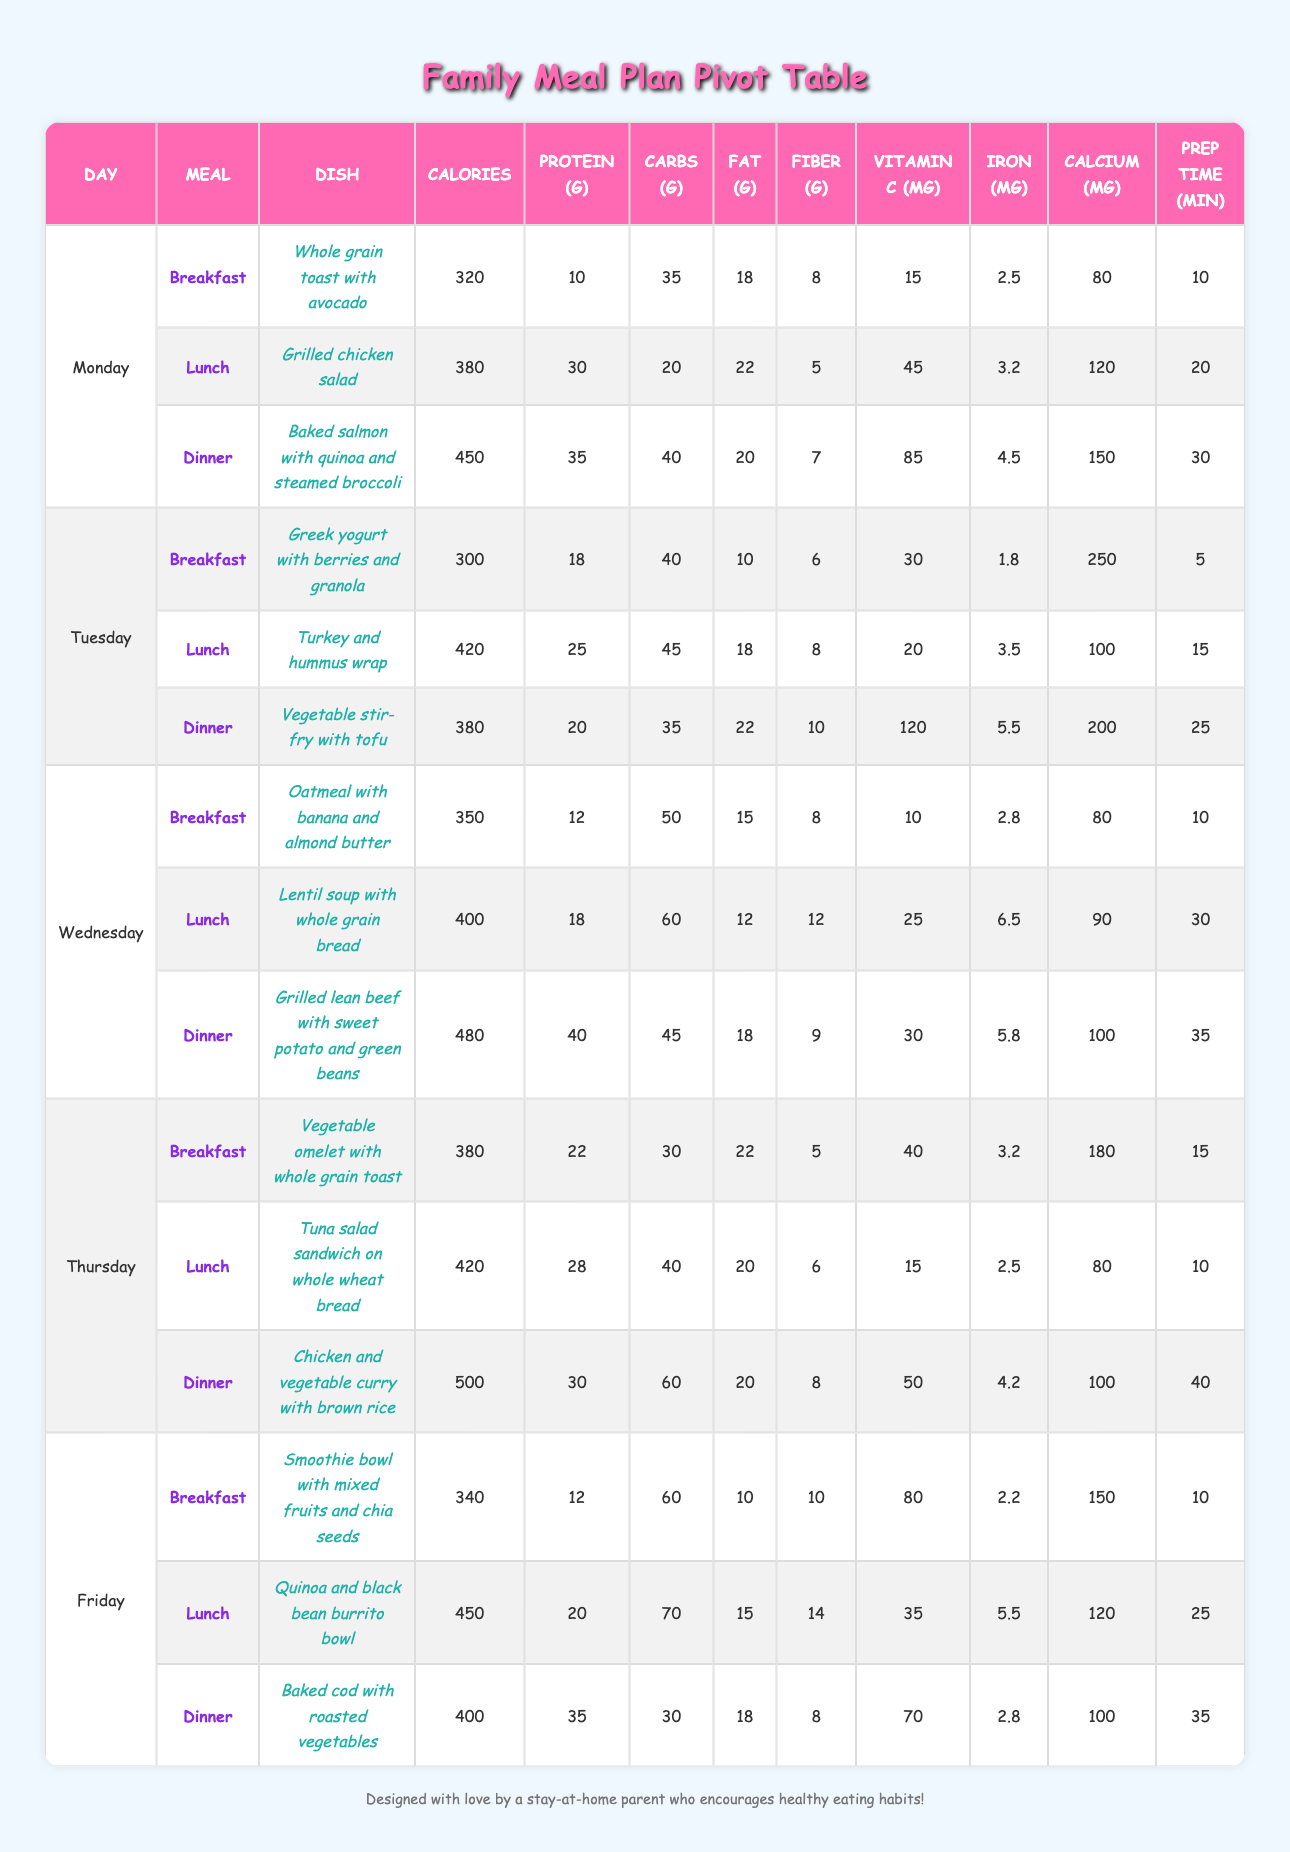What is the total calorie count for all dinners in the meal plan? To find the total calories for all dinners, we need to sum the calorie counts from each dinner entry in the table. The dinners are: 450 (Monday) + 380 (Tuesday) + 480 (Wednesday) + 500 (Thursday) + 400 (Friday) which equals 450 + 380 + 480 + 500 + 400 = 2180 calories.
Answer: 2180 Which dish has the highest vitamin C content? Looking through the vitamin C content for each dish, we can see that the "Vegetable stir-fry with tofu" on Tuesday has the highest value of 120 mg.
Answer: Vegetable stir-fry with tofu Is the total protein intake for Thursday greater than that for Wednesday? For Thursday, the total protein is 22 (breakfast) + 28 (lunch) + 30 (dinner) = 80 grams. For Wednesday, it is 12 + 18 + 40 = 70 grams. Since 80 grams > 70 grams, the protein intake for Thursday is indeed greater.
Answer: Yes What is the average carbs per meal on Monday? To find the average carbs for Monday, we first sum the carb counts for each meal: 35 (breakfast) + 20 (lunch) + 40 (dinner) = 95 grams. Since there are 3 meals, we divide 95 by 3 which yields 95 / 3 = 31.67 grams.
Answer: 31.67 For which meal on Friday is the fat content the lowest? Examining each meal's fat content on Friday: smoothie bowl has 10g, burrito bowl has 15g, and baked cod has 18g. The lowest fat content is from the smoothie bowl which has 10 grams of fat.
Answer: Smoothie bowl How much fiber does the lunch on Tuesday provide compared to the dinner on Thursday? The fiber from Tuesday's lunch (Turkey and hummus wrap) is 8 grams, and the fiber from Thursday's dinner (Chicken and vegetable curry) is 8 grams as well. Since both provide 8 grams, they are equal.
Answer: They provide the same amount of fiber Is it true that each meal on Wednesday has at least 10 grams of protein? Checking the protein content for Wednesday: breakfast has 12g, lunch has 18g, and dinner has 40g. All meals exceed 10 grams of protein, confirming the statement as true.
Answer: Yes What is the total prep time for all meals on Tuesday? To find the total prep time for Tuesday meals, we sum the prep times for breakfast (5 min), lunch (15 min), and dinner (25 min) yielding 5 + 15 + 25 = 45 minutes total prep time.
Answer: 45 minutes 